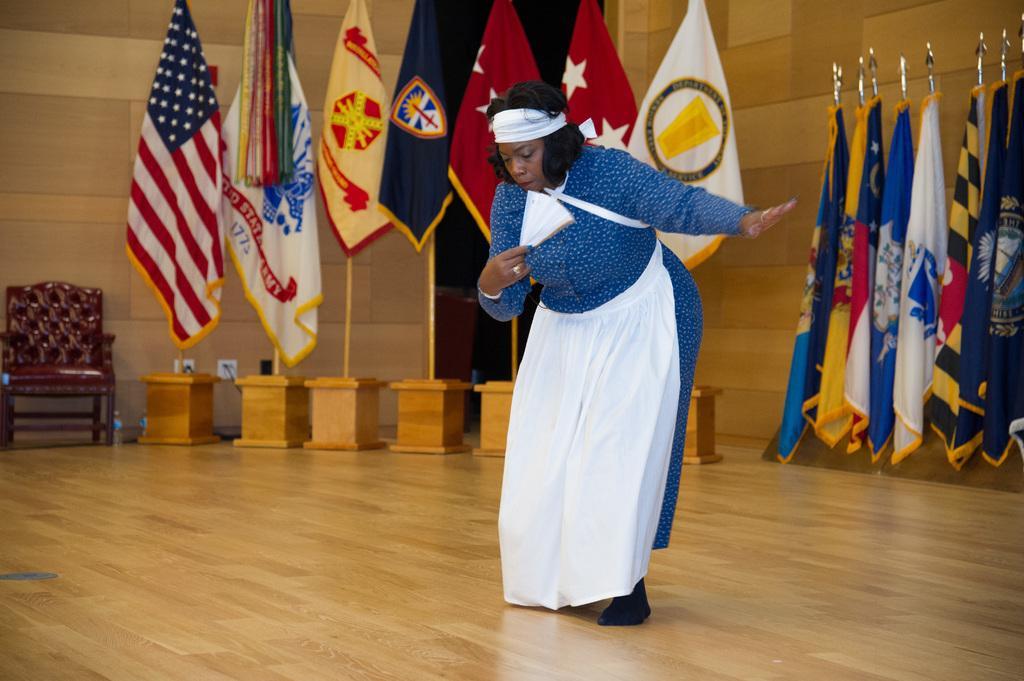Can you describe this image briefly? In this image a woman is dancing on the floor. She is holding an object in her hand. Behind her there are few poles having flags. Left side there is a chair on the floor. Background there is a wall. 